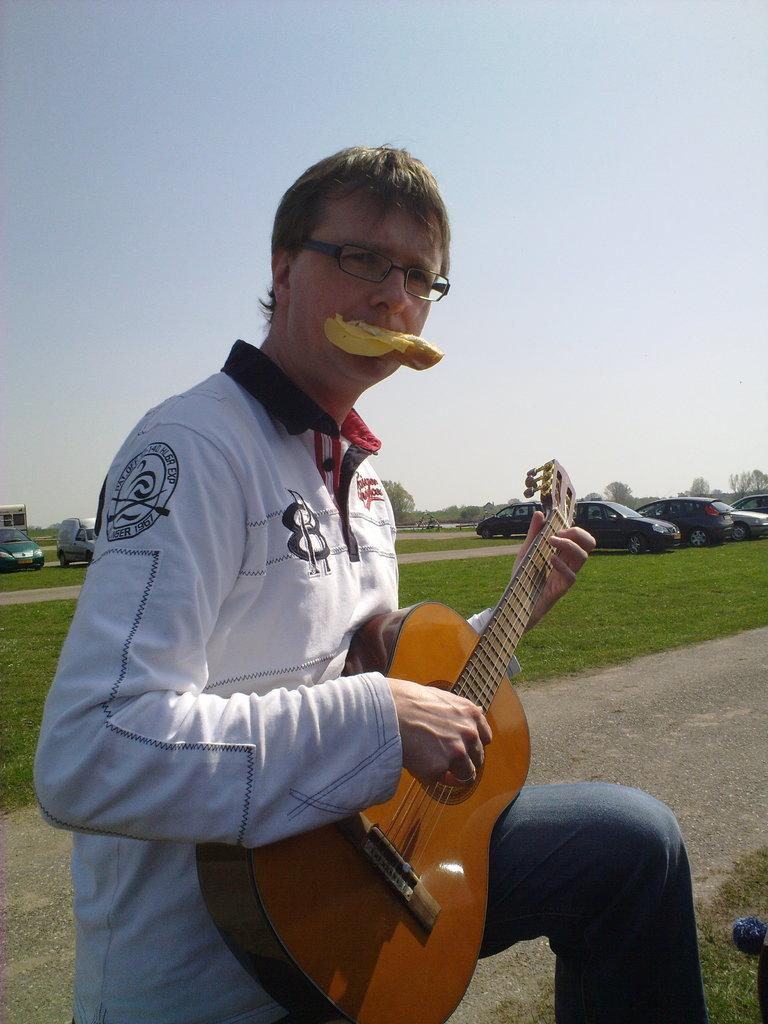Who is the main subject in the image? There is a man in the image. What is the man holding in the image? The man is holding a guitar. What can be seen in the background of the image? The sky is clear in the background of the image. Can you tell me how the man is helping the stream in the image? There is no stream present in the image, so the man is not helping a stream. 